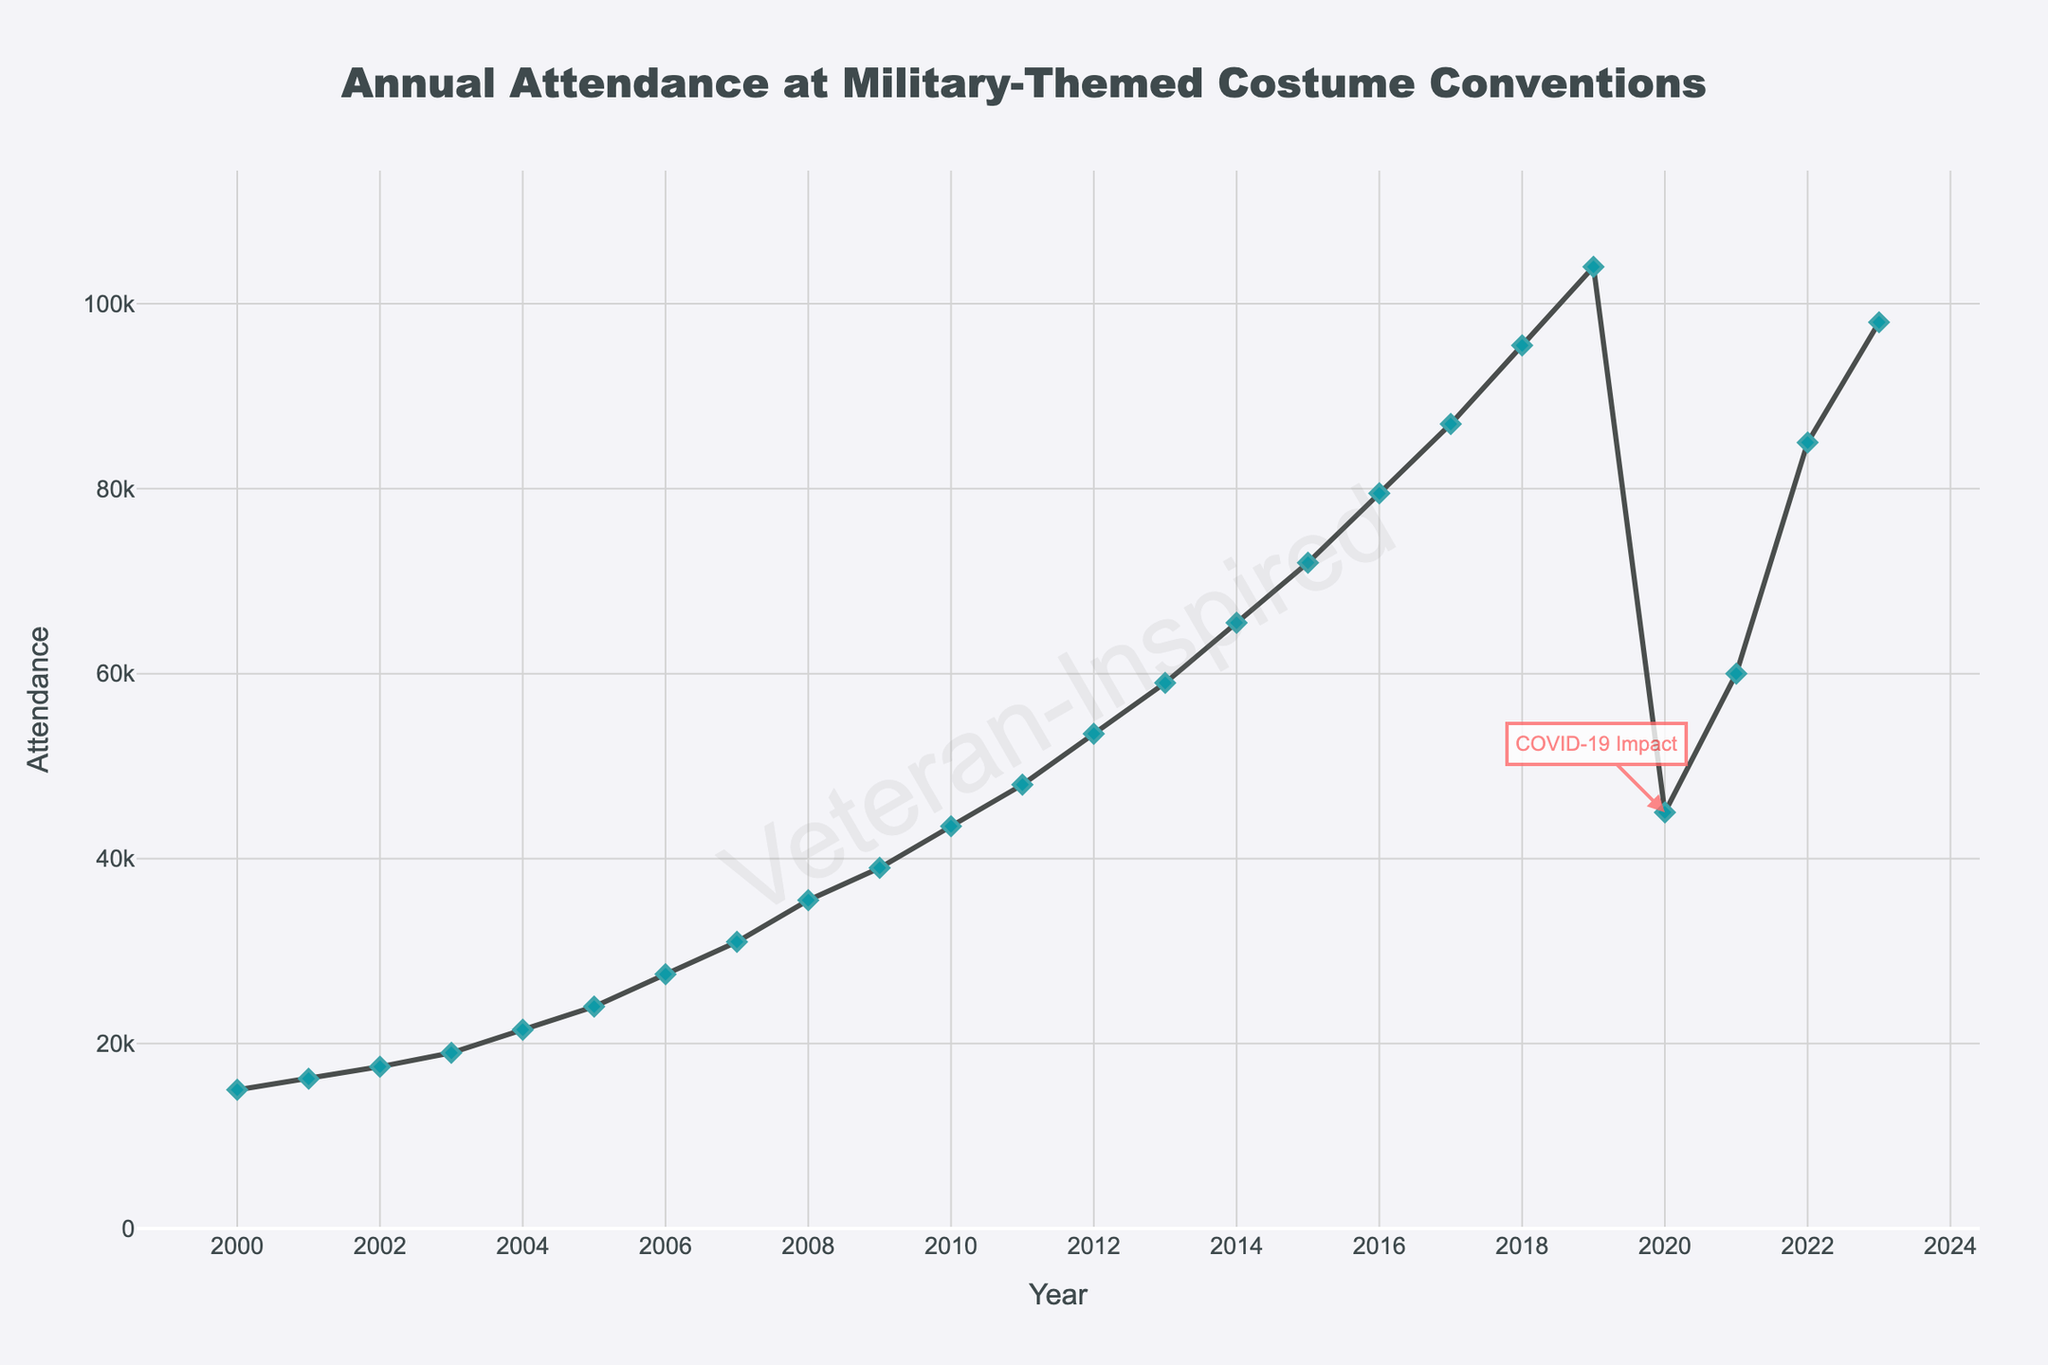What year had the highest attendance before 2020? Look for the peak attendance in the data before the year 2020. The highest attendance before 2020 was in 2019 with 104,000 attendees.
Answer: 2019 How did the attendance change between 2019 and 2020? Check the attendance values for 2019 and 2020. In 2019, the attendance was 104,000, and it dropped to 45,000 in 2020. The difference is 104,000 - 45,000 = 59,000.
Answer: Decreased by 59,000 Which year showed the greatest increase in attendance from the previous year? Compare the increase in attendance year over year by subtracting the previous year's attendance from the current year's attendance. The year 2012 to 2013 saw an increase from 53,500 to 59,000, which is an increase of 5,500. No other year saw a greater increase.
Answer: 2013 What are the overall trends in attendance from 2000 to 2019? Observing the line chart from 2000 to 2019, the attendance consistently increases almost every year, showing a strong upward trend.
Answer: Increasing trend In which years did the attendance notably drop? Look for years where there is a clear drop in the line chart. In 2020, there was a noticeable drop compared to 2019.
Answer: 2020 What can be inferred from the annotation on the chart? The annotation on the chart indicates that the significant drop in attendance in 2020 was due to the impact of COVID-19.
Answer: Impact of COVID-19 in 2020 How much did the attendance increase from 2021 to 2022? Check the attendance values for 2021 and 2022. In 2021, the attendance was 60,000, and in 2022, it was 85,000. The difference is 85,000 - 60,000 = 25,000.
Answer: Increased by 25,000 What is the visual watermark on the chart? Observing the chart, there is a large, faint text in the middle reading 'Veteran-Inspired'.
Answer: Veteran-Inspired 